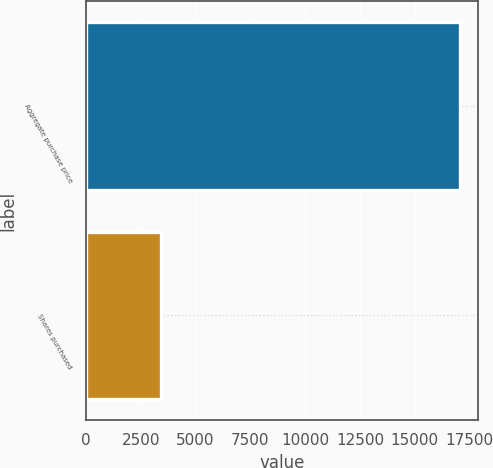<chart> <loc_0><loc_0><loc_500><loc_500><bar_chart><fcel>Aggregate purchase price<fcel>Shares purchased<nl><fcel>17060<fcel>3414<nl></chart> 